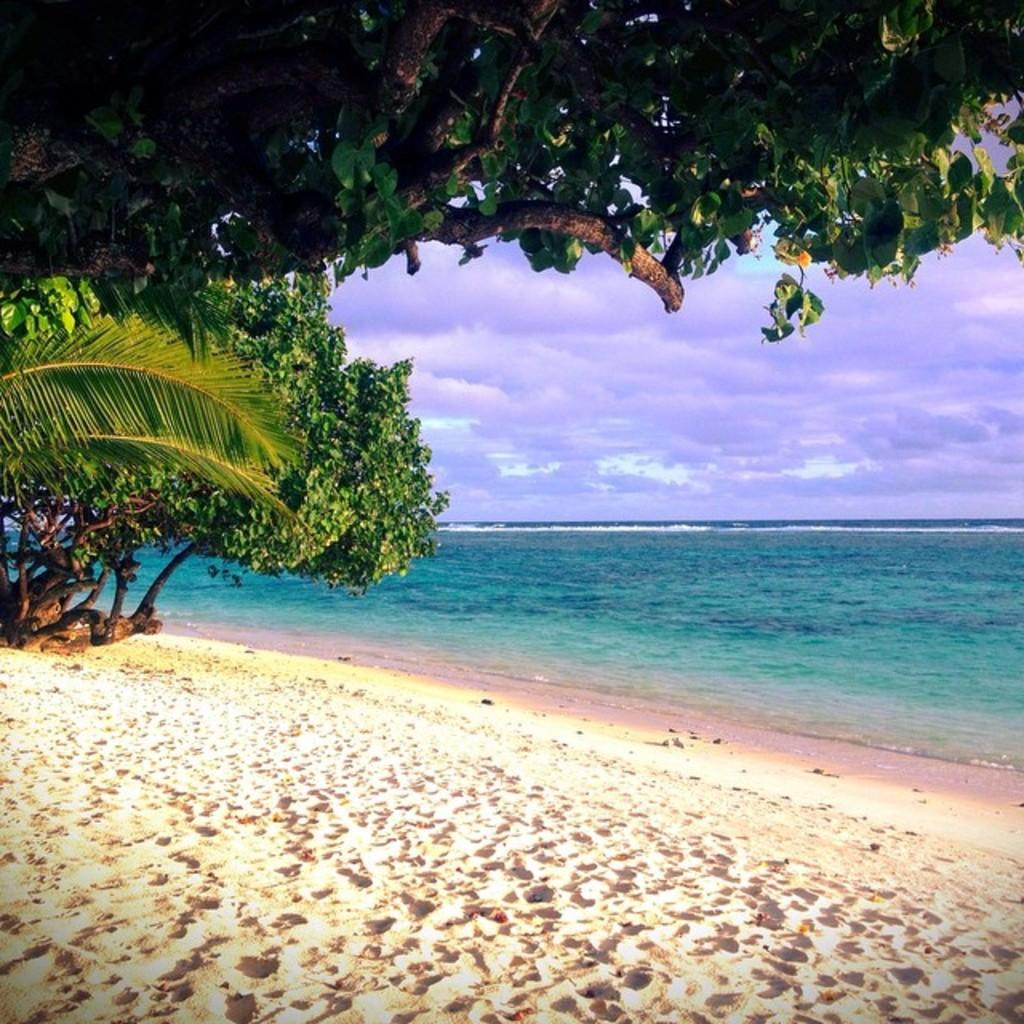What type of terrain is visible in the image? There is sand in the image. What type of vegetation can be seen in the image? There are trees in the image. What large body of water is visible in the image? The ocean is visible on the right side of the image. What is the condition of the sky in the image? The sky is clear in the image. Can you see a match being lit in the image? There is no match or any indication of fire in the image. What type of hope can be seen in the image? The image does not depict any specific hope or emotion; it is a landscape scene. 